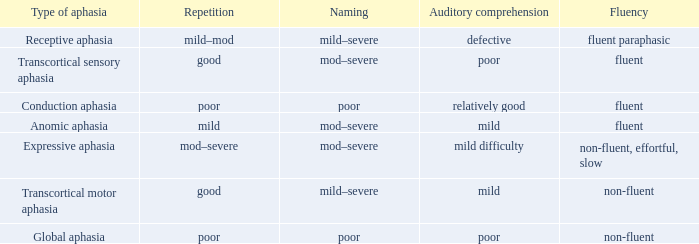What are the terms used to describe fluent and weak understanding? Mod–severe. 